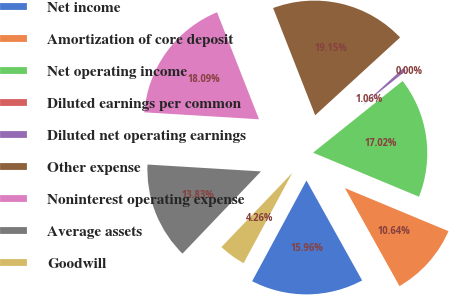Convert chart. <chart><loc_0><loc_0><loc_500><loc_500><pie_chart><fcel>Net income<fcel>Amortization of core deposit<fcel>Net operating income<fcel>Diluted earnings per common<fcel>Diluted net operating earnings<fcel>Other expense<fcel>Noninterest operating expense<fcel>Average assets<fcel>Goodwill<nl><fcel>15.96%<fcel>10.64%<fcel>17.02%<fcel>0.0%<fcel>1.06%<fcel>19.15%<fcel>18.09%<fcel>13.83%<fcel>4.26%<nl></chart> 